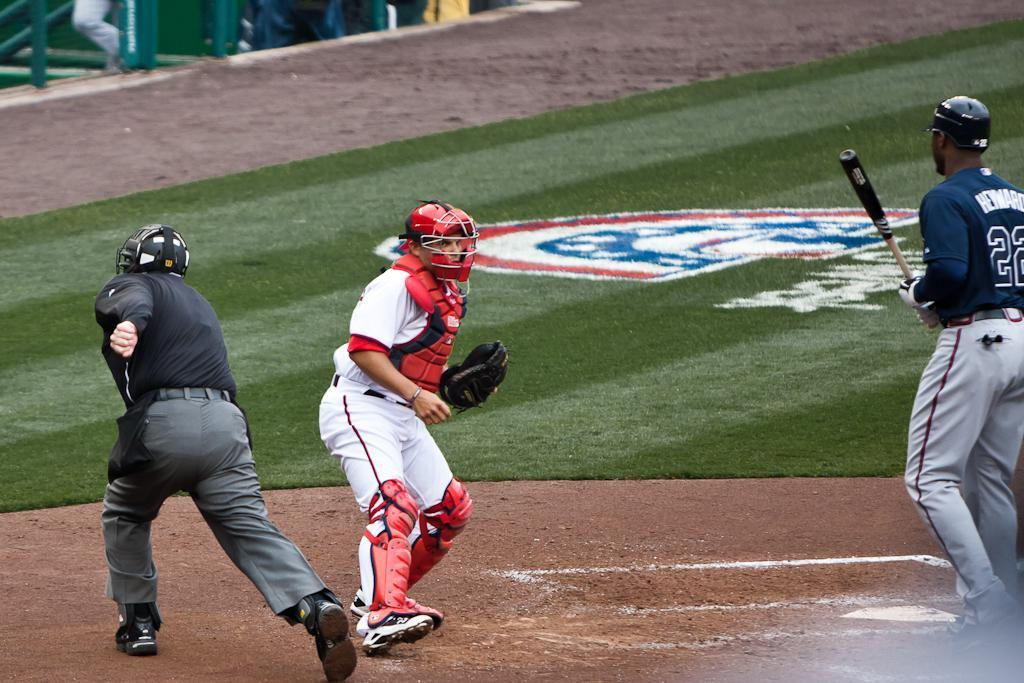<image>
Summarize the visual content of the image. A black man with Heward on the back of his jersey holds a baseball bat on the field. 